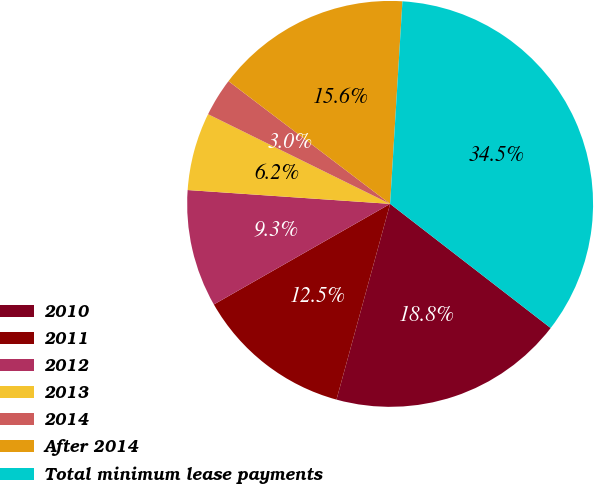Convert chart to OTSL. <chart><loc_0><loc_0><loc_500><loc_500><pie_chart><fcel>2010<fcel>2011<fcel>2012<fcel>2013<fcel>2014<fcel>After 2014<fcel>Total minimum lease payments<nl><fcel>18.78%<fcel>12.49%<fcel>9.34%<fcel>6.2%<fcel>3.05%<fcel>15.63%<fcel>34.51%<nl></chart> 